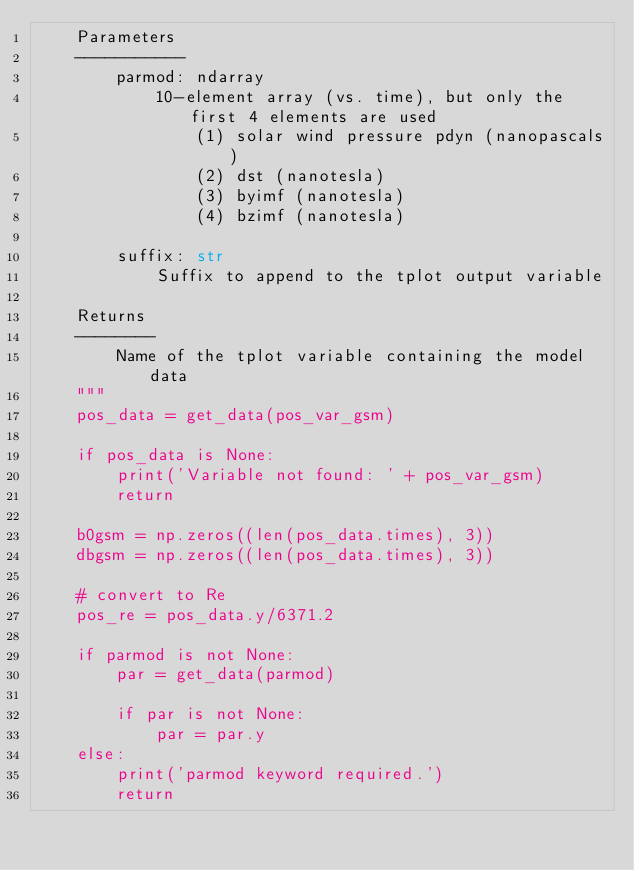<code> <loc_0><loc_0><loc_500><loc_500><_Python_>    Parameters
    -----------
        parmod: ndarray
            10-element array (vs. time), but only the first 4 elements are used
                (1) solar wind pressure pdyn (nanopascals)
                (2) dst (nanotesla)
                (3) byimf (nanotesla)
                (4) bzimf (nanotesla)

        suffix: str
            Suffix to append to the tplot output variable

    Returns
    --------
        Name of the tplot variable containing the model data
    """
    pos_data = get_data(pos_var_gsm)

    if pos_data is None:
        print('Variable not found: ' + pos_var_gsm)
        return

    b0gsm = np.zeros((len(pos_data.times), 3))
    dbgsm = np.zeros((len(pos_data.times), 3))

    # convert to Re
    pos_re = pos_data.y/6371.2

    if parmod is not None:
        par = get_data(parmod)

        if par is not None:
            par = par.y
    else:
        print('parmod keyword required.')
        return
</code> 